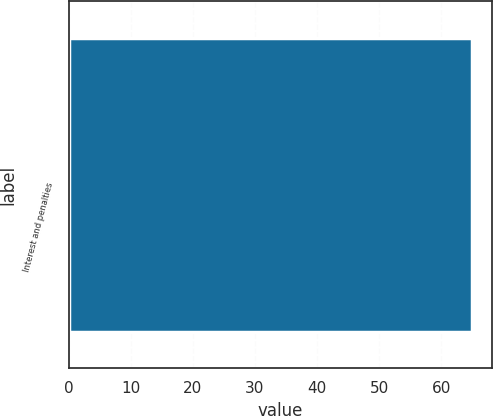Convert chart. <chart><loc_0><loc_0><loc_500><loc_500><bar_chart><fcel>Interest and penalties<nl><fcel>65<nl></chart> 